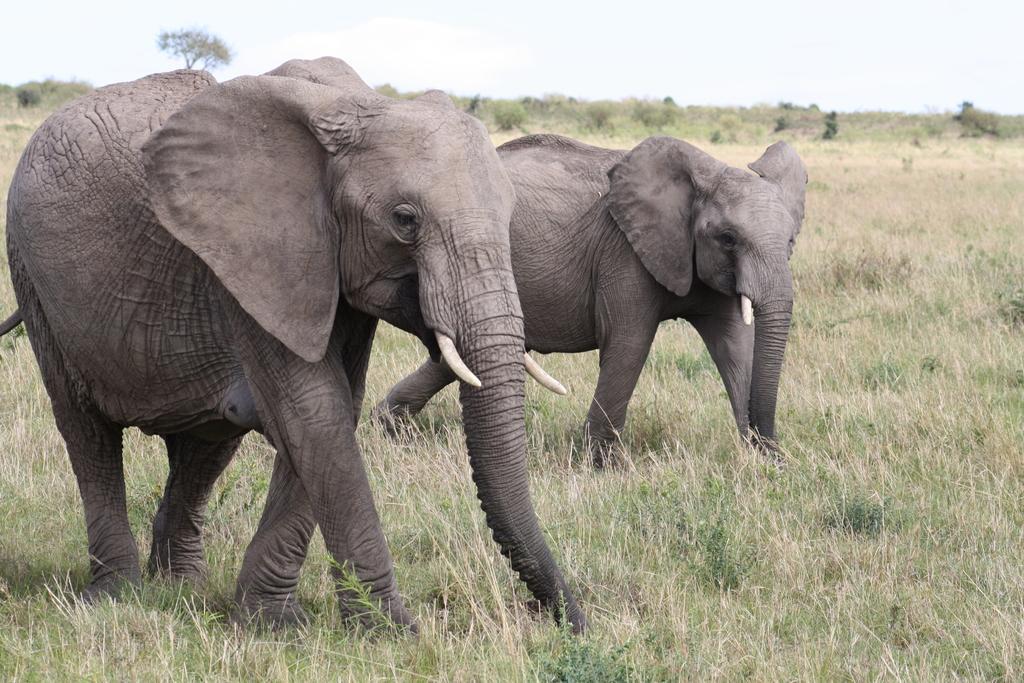How would you summarize this image in a sentence or two? This image I can see two elephants facing towards the right side. At the bottom, I can see the grass. In the background there are some trees. At the top, I can see the sky. 